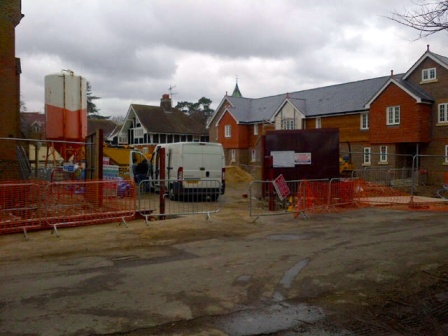Can you describe the main features of this image for me? The image presents a lively construction site under an overcast sky. In the foreground, there is a white truck parked parallel to a vivid red fence, acting as a barrier for a dirt-covered area. Inside this fenced-off region, a large construction vehicle painted in bright orange and white is visible. Further beyond this, several houses at different stages of construction hint at the development of a new residential neighborhood. One house, in particular, appears to be actively under construction. Despite the presence of textual signs in the image, the text is not clear enough to read, leaving the details of the project somewhat ambiguous. The overall scene paints a typical day at a construction site, where machinery is at rest, presumably awaiting the next wave of activity. 